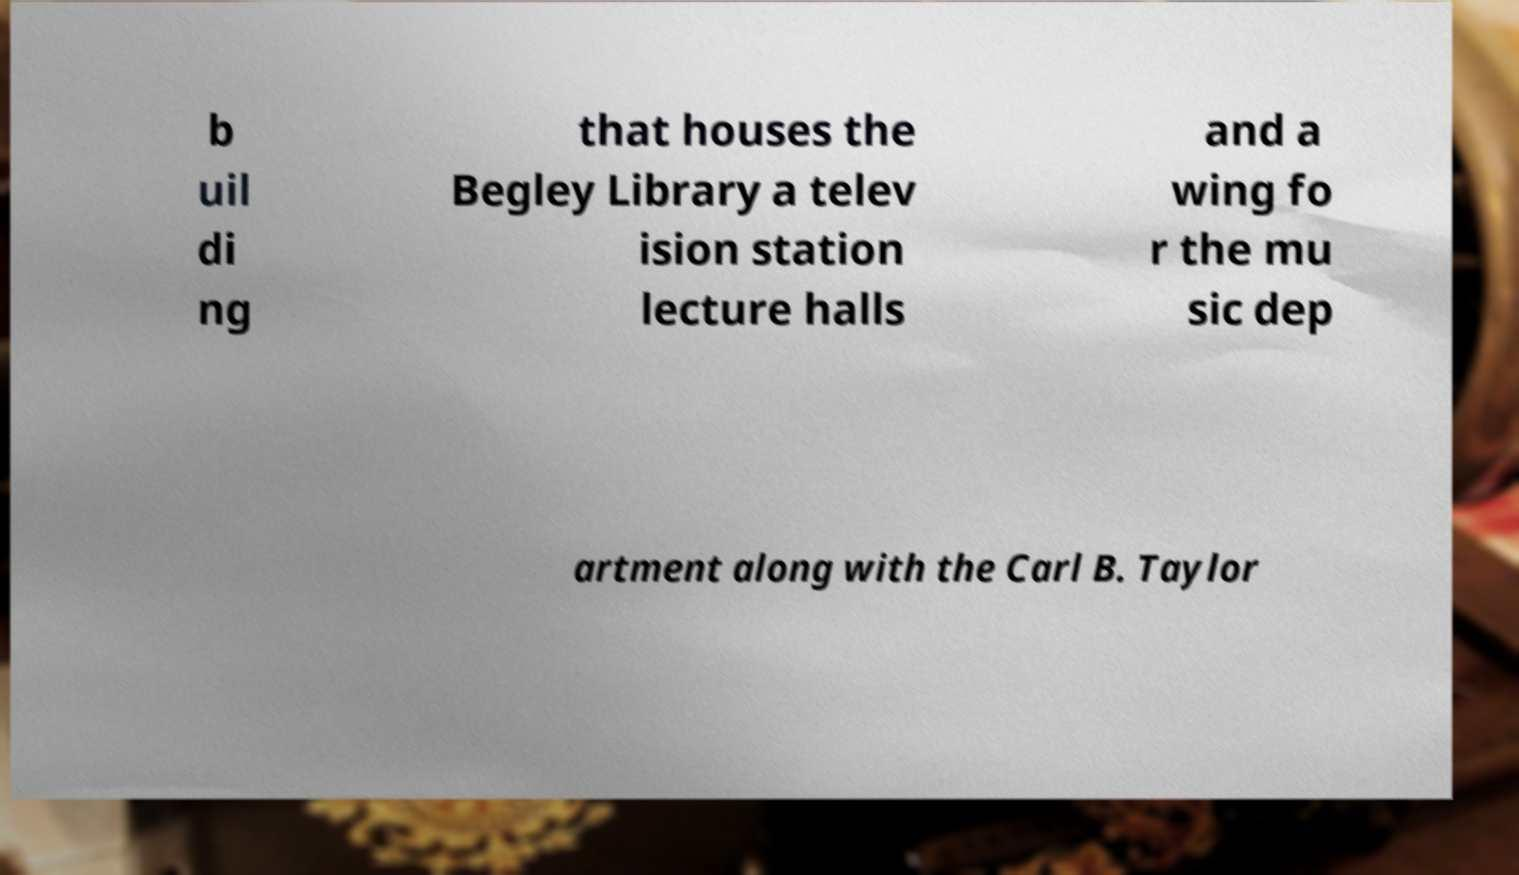There's text embedded in this image that I need extracted. Can you transcribe it verbatim? b uil di ng that houses the Begley Library a telev ision station lecture halls and a wing fo r the mu sic dep artment along with the Carl B. Taylor 